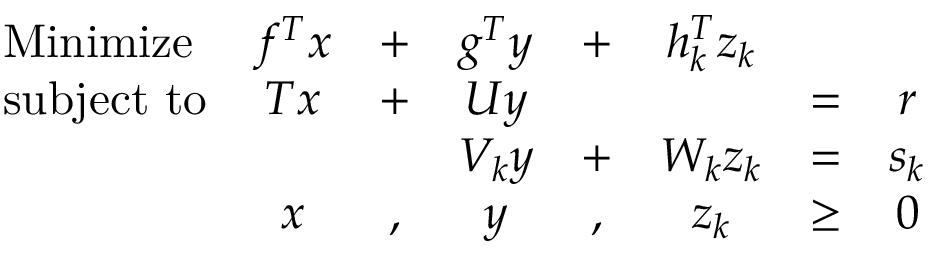Convert formula to latex. <formula><loc_0><loc_0><loc_500><loc_500>{ \begin{array} { l c c c c c c c } { M i n i m i z e } & { f ^ { T } x } & { + } & { g ^ { T } y } & { + } & { h _ { k } ^ { T } z _ { k } } & & \\ { s u b j e c t t o } & { T x } & { + } & { U y } & & & { = } & { r } \\ & & & { V _ { k } y } & { + } & { W _ { k } z _ { k } } & { = } & { s _ { k } } \\ & { x } & { , } & { y } & { , } & { z _ { k } } & { \geq } & { 0 } \end{array} }</formula> 